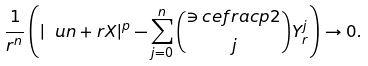<formula> <loc_0><loc_0><loc_500><loc_500>\frac { 1 } { r ^ { n } } \left ( | \ u n + r X | ^ { p } - \sum _ { j = 0 } ^ { n } \binom { \ni c e f r a c p 2 } { j } Y _ { r } ^ { j } \right ) \rightarrow 0 .</formula> 